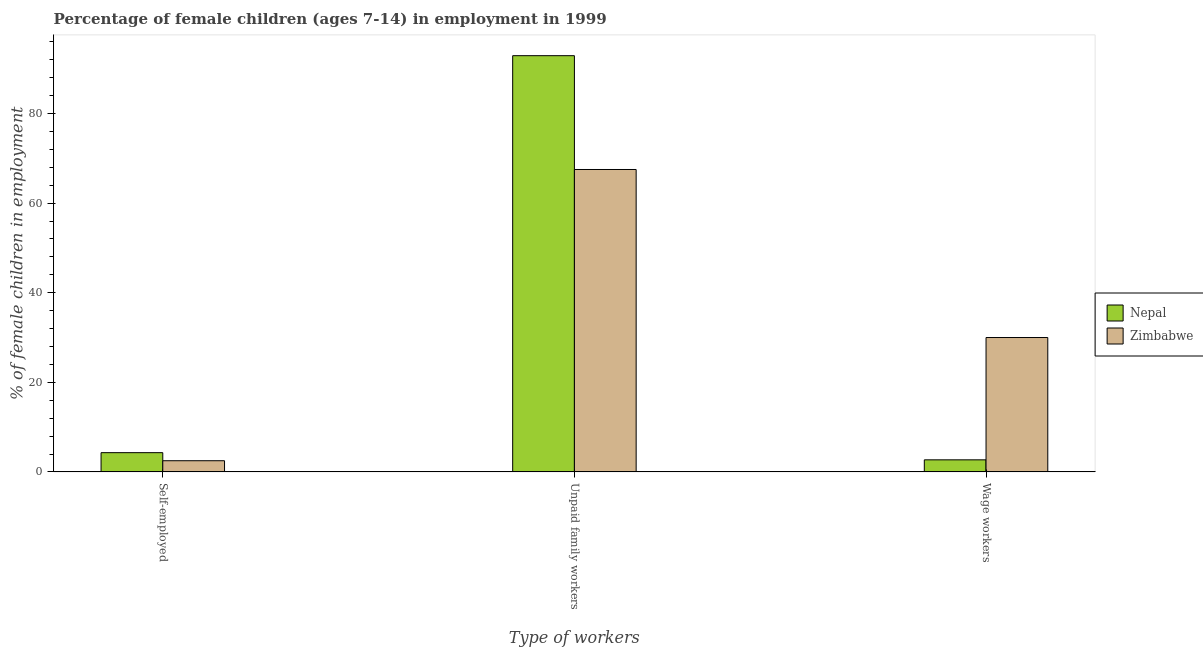How many bars are there on the 2nd tick from the right?
Make the answer very short. 2. What is the label of the 1st group of bars from the left?
Your answer should be compact. Self-employed. Across all countries, what is the maximum percentage of children employed as unpaid family workers?
Offer a terse response. 92.9. Across all countries, what is the minimum percentage of children employed as unpaid family workers?
Provide a succinct answer. 67.5. In which country was the percentage of self employed children maximum?
Your answer should be compact. Nepal. In which country was the percentage of children employed as wage workers minimum?
Offer a very short reply. Nepal. What is the total percentage of children employed as wage workers in the graph?
Offer a terse response. 32.7. What is the difference between the percentage of self employed children in Nepal and that in Zimbabwe?
Provide a short and direct response. 1.8. What is the difference between the percentage of self employed children in Nepal and the percentage of children employed as unpaid family workers in Zimbabwe?
Your answer should be very brief. -63.2. What is the average percentage of children employed as unpaid family workers per country?
Provide a succinct answer. 80.2. What is the difference between the percentage of children employed as unpaid family workers and percentage of children employed as wage workers in Nepal?
Ensure brevity in your answer.  90.2. What is the ratio of the percentage of children employed as unpaid family workers in Nepal to that in Zimbabwe?
Give a very brief answer. 1.38. What is the difference between the highest and the second highest percentage of children employed as unpaid family workers?
Your answer should be very brief. 25.4. What is the difference between the highest and the lowest percentage of children employed as unpaid family workers?
Ensure brevity in your answer.  25.4. Is the sum of the percentage of children employed as wage workers in Zimbabwe and Nepal greater than the maximum percentage of self employed children across all countries?
Provide a succinct answer. Yes. What does the 1st bar from the left in Unpaid family workers represents?
Offer a very short reply. Nepal. What does the 1st bar from the right in Wage workers represents?
Make the answer very short. Zimbabwe. Are all the bars in the graph horizontal?
Offer a terse response. No. How many countries are there in the graph?
Give a very brief answer. 2. Does the graph contain grids?
Ensure brevity in your answer.  No. Where does the legend appear in the graph?
Your answer should be compact. Center right. How many legend labels are there?
Make the answer very short. 2. How are the legend labels stacked?
Offer a terse response. Vertical. What is the title of the graph?
Give a very brief answer. Percentage of female children (ages 7-14) in employment in 1999. Does "Colombia" appear as one of the legend labels in the graph?
Give a very brief answer. No. What is the label or title of the X-axis?
Provide a short and direct response. Type of workers. What is the label or title of the Y-axis?
Offer a terse response. % of female children in employment. What is the % of female children in employment of Nepal in Self-employed?
Your response must be concise. 4.3. What is the % of female children in employment of Nepal in Unpaid family workers?
Your answer should be compact. 92.9. What is the % of female children in employment of Zimbabwe in Unpaid family workers?
Provide a short and direct response. 67.5. Across all Type of workers, what is the maximum % of female children in employment of Nepal?
Your answer should be very brief. 92.9. Across all Type of workers, what is the maximum % of female children in employment of Zimbabwe?
Ensure brevity in your answer.  67.5. Across all Type of workers, what is the minimum % of female children in employment of Nepal?
Provide a short and direct response. 2.7. Across all Type of workers, what is the minimum % of female children in employment in Zimbabwe?
Keep it short and to the point. 2.5. What is the total % of female children in employment of Nepal in the graph?
Your response must be concise. 99.9. What is the difference between the % of female children in employment of Nepal in Self-employed and that in Unpaid family workers?
Offer a very short reply. -88.6. What is the difference between the % of female children in employment in Zimbabwe in Self-employed and that in Unpaid family workers?
Your response must be concise. -65. What is the difference between the % of female children in employment in Nepal in Self-employed and that in Wage workers?
Provide a succinct answer. 1.6. What is the difference between the % of female children in employment of Zimbabwe in Self-employed and that in Wage workers?
Provide a short and direct response. -27.5. What is the difference between the % of female children in employment of Nepal in Unpaid family workers and that in Wage workers?
Give a very brief answer. 90.2. What is the difference between the % of female children in employment in Zimbabwe in Unpaid family workers and that in Wage workers?
Keep it short and to the point. 37.5. What is the difference between the % of female children in employment in Nepal in Self-employed and the % of female children in employment in Zimbabwe in Unpaid family workers?
Offer a terse response. -63.2. What is the difference between the % of female children in employment in Nepal in Self-employed and the % of female children in employment in Zimbabwe in Wage workers?
Give a very brief answer. -25.7. What is the difference between the % of female children in employment in Nepal in Unpaid family workers and the % of female children in employment in Zimbabwe in Wage workers?
Your answer should be very brief. 62.9. What is the average % of female children in employment in Nepal per Type of workers?
Your response must be concise. 33.3. What is the average % of female children in employment of Zimbabwe per Type of workers?
Offer a terse response. 33.33. What is the difference between the % of female children in employment of Nepal and % of female children in employment of Zimbabwe in Unpaid family workers?
Your answer should be compact. 25.4. What is the difference between the % of female children in employment of Nepal and % of female children in employment of Zimbabwe in Wage workers?
Make the answer very short. -27.3. What is the ratio of the % of female children in employment in Nepal in Self-employed to that in Unpaid family workers?
Your answer should be very brief. 0.05. What is the ratio of the % of female children in employment of Zimbabwe in Self-employed to that in Unpaid family workers?
Make the answer very short. 0.04. What is the ratio of the % of female children in employment in Nepal in Self-employed to that in Wage workers?
Ensure brevity in your answer.  1.59. What is the ratio of the % of female children in employment of Zimbabwe in Self-employed to that in Wage workers?
Make the answer very short. 0.08. What is the ratio of the % of female children in employment in Nepal in Unpaid family workers to that in Wage workers?
Offer a terse response. 34.41. What is the ratio of the % of female children in employment of Zimbabwe in Unpaid family workers to that in Wage workers?
Offer a very short reply. 2.25. What is the difference between the highest and the second highest % of female children in employment of Nepal?
Provide a succinct answer. 88.6. What is the difference between the highest and the second highest % of female children in employment in Zimbabwe?
Offer a very short reply. 37.5. What is the difference between the highest and the lowest % of female children in employment of Nepal?
Offer a terse response. 90.2. 